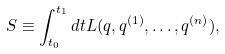Convert formula to latex. <formula><loc_0><loc_0><loc_500><loc_500>S \equiv \int _ { t _ { 0 } } ^ { t _ { 1 } } d t L ( q , q ^ { ( 1 ) } , \dots , q ^ { ( n ) } ) ,</formula> 